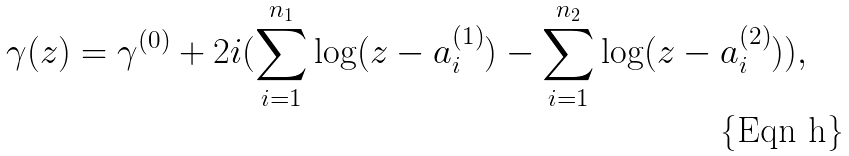<formula> <loc_0><loc_0><loc_500><loc_500>\gamma ( z ) = \gamma ^ { ( 0 ) } + 2 i ( \sum _ { i = 1 } ^ { n _ { 1 } } \log ( z - a _ { i } ^ { ( 1 ) } ) - \sum _ { i = 1 } ^ { n _ { 2 } } \log ( z - a _ { i } ^ { ( 2 ) } ) ) ,</formula> 